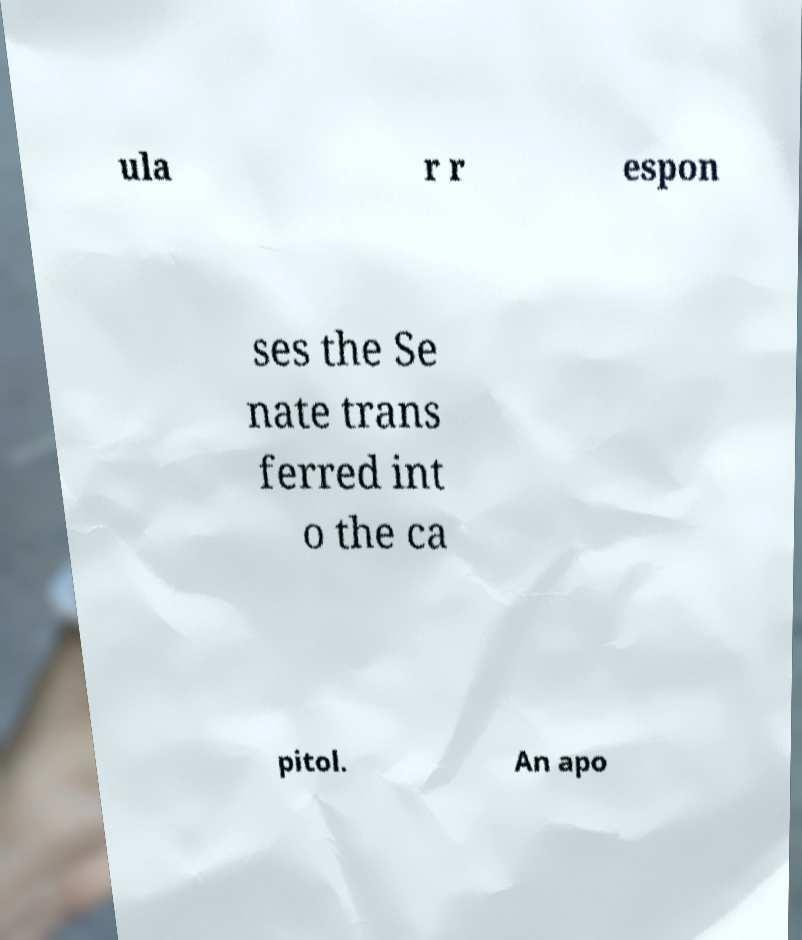Can you accurately transcribe the text from the provided image for me? ula r r espon ses the Se nate trans ferred int o the ca pitol. An apo 